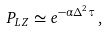<formula> <loc_0><loc_0><loc_500><loc_500>P _ { L Z } \simeq e ^ { - \alpha \Delta ^ { 2 } \tau } \, ,</formula> 